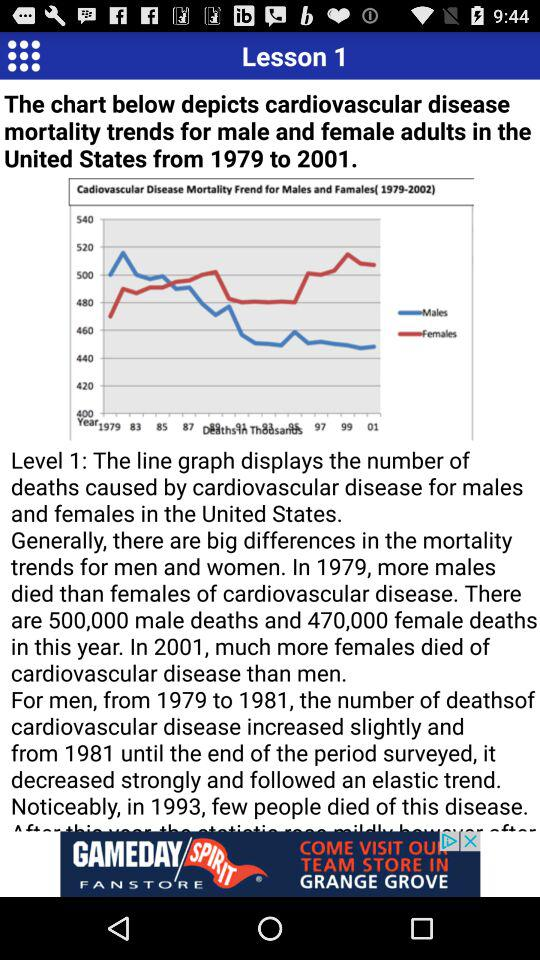How many females have died?
Answer the question using a single word or phrase. The died females are 470,000 